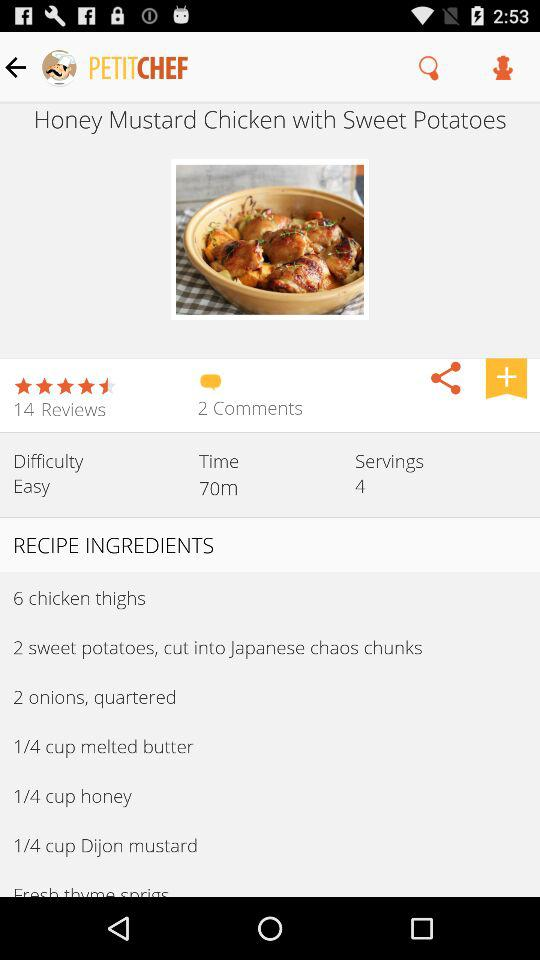What is the name of the recipe? The name of the recipe is honey mustard chicken with sweet potatoes. 